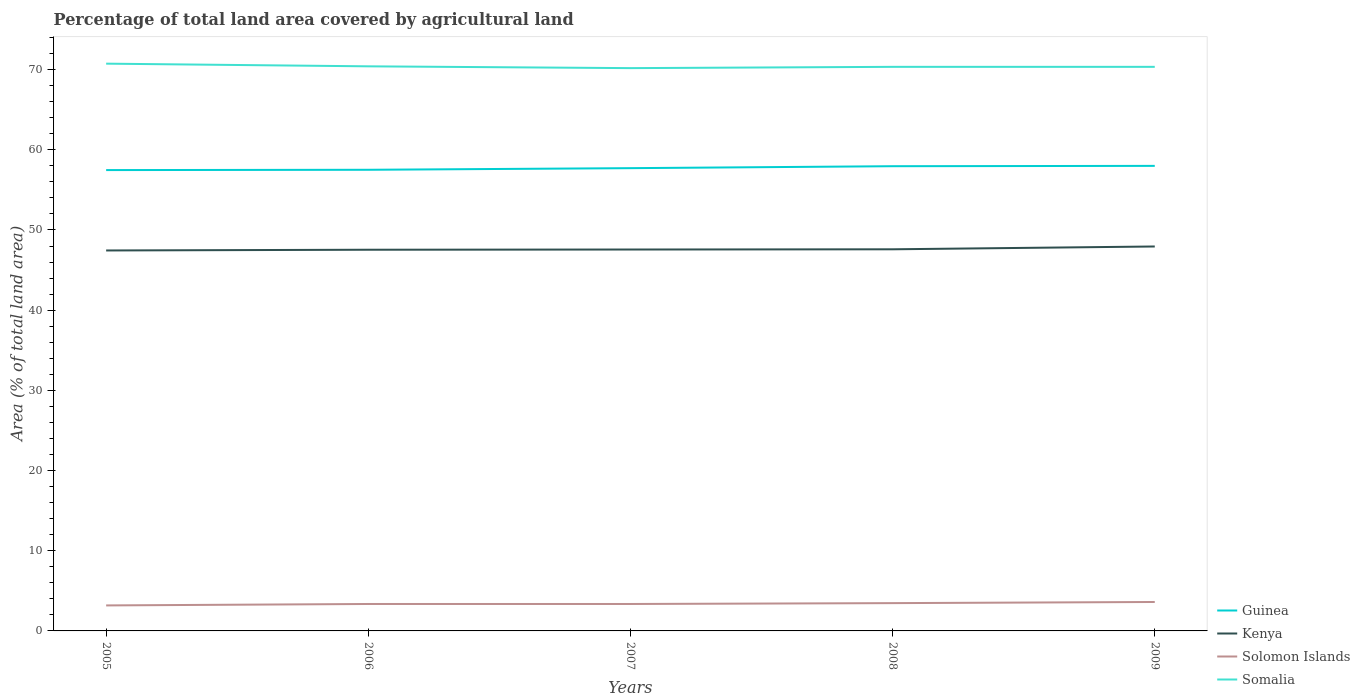Does the line corresponding to Solomon Islands intersect with the line corresponding to Kenya?
Your answer should be very brief. No. Across all years, what is the maximum percentage of agricultural land in Guinea?
Your answer should be very brief. 57.47. In which year was the percentage of agricultural land in Kenya maximum?
Offer a terse response. 2005. What is the total percentage of agricultural land in Guinea in the graph?
Your response must be concise. -0.2. What is the difference between the highest and the second highest percentage of agricultural land in Kenya?
Ensure brevity in your answer.  0.5. What is the difference between the highest and the lowest percentage of agricultural land in Guinea?
Make the answer very short. 2. Is the percentage of agricultural land in Guinea strictly greater than the percentage of agricultural land in Kenya over the years?
Provide a short and direct response. No. How many lines are there?
Ensure brevity in your answer.  4. What is the difference between two consecutive major ticks on the Y-axis?
Your answer should be compact. 10. Does the graph contain grids?
Your answer should be compact. No. How many legend labels are there?
Give a very brief answer. 4. What is the title of the graph?
Make the answer very short. Percentage of total land area covered by agricultural land. Does "Djibouti" appear as one of the legend labels in the graph?
Your answer should be very brief. No. What is the label or title of the Y-axis?
Provide a succinct answer. Area (% of total land area). What is the Area (% of total land area) of Guinea in 2005?
Your answer should be compact. 57.47. What is the Area (% of total land area) in Kenya in 2005?
Your response must be concise. 47.44. What is the Area (% of total land area) of Solomon Islands in 2005?
Give a very brief answer. 3.18. What is the Area (% of total land area) in Somalia in 2005?
Your response must be concise. 70.74. What is the Area (% of total land area) of Guinea in 2006?
Offer a very short reply. 57.5. What is the Area (% of total land area) in Kenya in 2006?
Make the answer very short. 47.53. What is the Area (% of total land area) in Solomon Islands in 2006?
Ensure brevity in your answer.  3.36. What is the Area (% of total land area) in Somalia in 2006?
Your answer should be compact. 70.41. What is the Area (% of total land area) of Guinea in 2007?
Provide a short and direct response. 57.71. What is the Area (% of total land area) in Kenya in 2007?
Keep it short and to the point. 47.56. What is the Area (% of total land area) of Solomon Islands in 2007?
Give a very brief answer. 3.36. What is the Area (% of total land area) of Somalia in 2007?
Offer a very short reply. 70.18. What is the Area (% of total land area) in Guinea in 2008?
Offer a terse response. 57.95. What is the Area (% of total land area) in Kenya in 2008?
Keep it short and to the point. 47.59. What is the Area (% of total land area) in Solomon Islands in 2008?
Your answer should be compact. 3.47. What is the Area (% of total land area) of Somalia in 2008?
Keep it short and to the point. 70.34. What is the Area (% of total land area) of Guinea in 2009?
Your response must be concise. 57.99. What is the Area (% of total land area) of Kenya in 2009?
Your answer should be compact. 47.94. What is the Area (% of total land area) in Solomon Islands in 2009?
Your response must be concise. 3.61. What is the Area (% of total land area) in Somalia in 2009?
Offer a very short reply. 70.34. Across all years, what is the maximum Area (% of total land area) in Guinea?
Your answer should be compact. 57.99. Across all years, what is the maximum Area (% of total land area) in Kenya?
Your answer should be very brief. 47.94. Across all years, what is the maximum Area (% of total land area) of Solomon Islands?
Your response must be concise. 3.61. Across all years, what is the maximum Area (% of total land area) of Somalia?
Ensure brevity in your answer.  70.74. Across all years, what is the minimum Area (% of total land area) of Guinea?
Provide a succinct answer. 57.47. Across all years, what is the minimum Area (% of total land area) of Kenya?
Offer a terse response. 47.44. Across all years, what is the minimum Area (% of total land area) in Solomon Islands?
Make the answer very short. 3.18. Across all years, what is the minimum Area (% of total land area) of Somalia?
Give a very brief answer. 70.18. What is the total Area (% of total land area) in Guinea in the graph?
Your response must be concise. 288.63. What is the total Area (% of total land area) of Kenya in the graph?
Your answer should be very brief. 238.07. What is the total Area (% of total land area) in Solomon Islands in the graph?
Your answer should be very brief. 16.97. What is the total Area (% of total land area) in Somalia in the graph?
Provide a succinct answer. 352.01. What is the difference between the Area (% of total land area) of Guinea in 2005 and that in 2006?
Your response must be concise. -0.04. What is the difference between the Area (% of total land area) of Kenya in 2005 and that in 2006?
Offer a terse response. -0.09. What is the difference between the Area (% of total land area) of Solomon Islands in 2005 and that in 2006?
Provide a succinct answer. -0.18. What is the difference between the Area (% of total land area) of Somalia in 2005 and that in 2006?
Your answer should be compact. 0.33. What is the difference between the Area (% of total land area) in Guinea in 2005 and that in 2007?
Offer a very short reply. -0.24. What is the difference between the Area (% of total land area) of Kenya in 2005 and that in 2007?
Offer a very short reply. -0.12. What is the difference between the Area (% of total land area) in Solomon Islands in 2005 and that in 2007?
Provide a succinct answer. -0.18. What is the difference between the Area (% of total land area) of Somalia in 2005 and that in 2007?
Your answer should be compact. 0.56. What is the difference between the Area (% of total land area) in Guinea in 2005 and that in 2008?
Keep it short and to the point. -0.48. What is the difference between the Area (% of total land area) in Kenya in 2005 and that in 2008?
Your answer should be very brief. -0.15. What is the difference between the Area (% of total land area) of Solomon Islands in 2005 and that in 2008?
Your answer should be compact. -0.29. What is the difference between the Area (% of total land area) of Somalia in 2005 and that in 2008?
Your response must be concise. 0.4. What is the difference between the Area (% of total land area) in Guinea in 2005 and that in 2009?
Offer a very short reply. -0.53. What is the difference between the Area (% of total land area) in Kenya in 2005 and that in 2009?
Offer a terse response. -0.5. What is the difference between the Area (% of total land area) in Solomon Islands in 2005 and that in 2009?
Provide a succinct answer. -0.43. What is the difference between the Area (% of total land area) in Somalia in 2005 and that in 2009?
Offer a terse response. 0.4. What is the difference between the Area (% of total land area) of Guinea in 2006 and that in 2007?
Provide a succinct answer. -0.2. What is the difference between the Area (% of total land area) in Kenya in 2006 and that in 2007?
Keep it short and to the point. -0.03. What is the difference between the Area (% of total land area) in Somalia in 2006 and that in 2007?
Your response must be concise. 0.22. What is the difference between the Area (% of total land area) in Guinea in 2006 and that in 2008?
Make the answer very short. -0.45. What is the difference between the Area (% of total land area) in Kenya in 2006 and that in 2008?
Your answer should be compact. -0.05. What is the difference between the Area (% of total land area) of Solomon Islands in 2006 and that in 2008?
Your answer should be compact. -0.11. What is the difference between the Area (% of total land area) in Somalia in 2006 and that in 2008?
Your answer should be compact. 0.06. What is the difference between the Area (% of total land area) in Guinea in 2006 and that in 2009?
Make the answer very short. -0.49. What is the difference between the Area (% of total land area) of Kenya in 2006 and that in 2009?
Make the answer very short. -0.41. What is the difference between the Area (% of total land area) of Solomon Islands in 2006 and that in 2009?
Keep it short and to the point. -0.25. What is the difference between the Area (% of total land area) in Somalia in 2006 and that in 2009?
Make the answer very short. 0.06. What is the difference between the Area (% of total land area) in Guinea in 2007 and that in 2008?
Keep it short and to the point. -0.24. What is the difference between the Area (% of total land area) in Kenya in 2007 and that in 2008?
Offer a very short reply. -0.03. What is the difference between the Area (% of total land area) of Solomon Islands in 2007 and that in 2008?
Offer a very short reply. -0.11. What is the difference between the Area (% of total land area) in Somalia in 2007 and that in 2008?
Make the answer very short. -0.16. What is the difference between the Area (% of total land area) in Guinea in 2007 and that in 2009?
Keep it short and to the point. -0.28. What is the difference between the Area (% of total land area) of Kenya in 2007 and that in 2009?
Offer a very short reply. -0.38. What is the difference between the Area (% of total land area) in Solomon Islands in 2007 and that in 2009?
Ensure brevity in your answer.  -0.25. What is the difference between the Area (% of total land area) in Somalia in 2007 and that in 2009?
Offer a terse response. -0.16. What is the difference between the Area (% of total land area) of Guinea in 2008 and that in 2009?
Your response must be concise. -0.04. What is the difference between the Area (% of total land area) in Kenya in 2008 and that in 2009?
Your answer should be very brief. -0.35. What is the difference between the Area (% of total land area) of Solomon Islands in 2008 and that in 2009?
Your answer should be compact. -0.14. What is the difference between the Area (% of total land area) of Guinea in 2005 and the Area (% of total land area) of Kenya in 2006?
Offer a very short reply. 9.93. What is the difference between the Area (% of total land area) of Guinea in 2005 and the Area (% of total land area) of Solomon Islands in 2006?
Give a very brief answer. 54.11. What is the difference between the Area (% of total land area) of Guinea in 2005 and the Area (% of total land area) of Somalia in 2006?
Your answer should be very brief. -12.94. What is the difference between the Area (% of total land area) of Kenya in 2005 and the Area (% of total land area) of Solomon Islands in 2006?
Make the answer very short. 44.09. What is the difference between the Area (% of total land area) in Kenya in 2005 and the Area (% of total land area) in Somalia in 2006?
Your response must be concise. -22.96. What is the difference between the Area (% of total land area) in Solomon Islands in 2005 and the Area (% of total land area) in Somalia in 2006?
Ensure brevity in your answer.  -67.23. What is the difference between the Area (% of total land area) in Guinea in 2005 and the Area (% of total land area) in Kenya in 2007?
Give a very brief answer. 9.9. What is the difference between the Area (% of total land area) in Guinea in 2005 and the Area (% of total land area) in Solomon Islands in 2007?
Your answer should be very brief. 54.11. What is the difference between the Area (% of total land area) of Guinea in 2005 and the Area (% of total land area) of Somalia in 2007?
Provide a succinct answer. -12.71. What is the difference between the Area (% of total land area) in Kenya in 2005 and the Area (% of total land area) in Solomon Islands in 2007?
Make the answer very short. 44.09. What is the difference between the Area (% of total land area) of Kenya in 2005 and the Area (% of total land area) of Somalia in 2007?
Keep it short and to the point. -22.74. What is the difference between the Area (% of total land area) of Solomon Islands in 2005 and the Area (% of total land area) of Somalia in 2007?
Your response must be concise. -67. What is the difference between the Area (% of total land area) in Guinea in 2005 and the Area (% of total land area) in Kenya in 2008?
Your answer should be compact. 9.88. What is the difference between the Area (% of total land area) of Guinea in 2005 and the Area (% of total land area) of Solomon Islands in 2008?
Offer a very short reply. 54. What is the difference between the Area (% of total land area) in Guinea in 2005 and the Area (% of total land area) in Somalia in 2008?
Keep it short and to the point. -12.87. What is the difference between the Area (% of total land area) in Kenya in 2005 and the Area (% of total land area) in Solomon Islands in 2008?
Provide a succinct answer. 43.98. What is the difference between the Area (% of total land area) of Kenya in 2005 and the Area (% of total land area) of Somalia in 2008?
Offer a very short reply. -22.9. What is the difference between the Area (% of total land area) in Solomon Islands in 2005 and the Area (% of total land area) in Somalia in 2008?
Your response must be concise. -67.16. What is the difference between the Area (% of total land area) of Guinea in 2005 and the Area (% of total land area) of Kenya in 2009?
Ensure brevity in your answer.  9.53. What is the difference between the Area (% of total land area) in Guinea in 2005 and the Area (% of total land area) in Solomon Islands in 2009?
Your answer should be very brief. 53.86. What is the difference between the Area (% of total land area) of Guinea in 2005 and the Area (% of total land area) of Somalia in 2009?
Your answer should be very brief. -12.87. What is the difference between the Area (% of total land area) of Kenya in 2005 and the Area (% of total land area) of Solomon Islands in 2009?
Keep it short and to the point. 43.84. What is the difference between the Area (% of total land area) of Kenya in 2005 and the Area (% of total land area) of Somalia in 2009?
Your response must be concise. -22.9. What is the difference between the Area (% of total land area) in Solomon Islands in 2005 and the Area (% of total land area) in Somalia in 2009?
Offer a very short reply. -67.16. What is the difference between the Area (% of total land area) of Guinea in 2006 and the Area (% of total land area) of Kenya in 2007?
Ensure brevity in your answer.  9.94. What is the difference between the Area (% of total land area) of Guinea in 2006 and the Area (% of total land area) of Solomon Islands in 2007?
Provide a succinct answer. 54.15. What is the difference between the Area (% of total land area) in Guinea in 2006 and the Area (% of total land area) in Somalia in 2007?
Provide a succinct answer. -12.68. What is the difference between the Area (% of total land area) in Kenya in 2006 and the Area (% of total land area) in Solomon Islands in 2007?
Your answer should be compact. 44.18. What is the difference between the Area (% of total land area) of Kenya in 2006 and the Area (% of total land area) of Somalia in 2007?
Ensure brevity in your answer.  -22.65. What is the difference between the Area (% of total land area) in Solomon Islands in 2006 and the Area (% of total land area) in Somalia in 2007?
Make the answer very short. -66.82. What is the difference between the Area (% of total land area) in Guinea in 2006 and the Area (% of total land area) in Kenya in 2008?
Provide a succinct answer. 9.92. What is the difference between the Area (% of total land area) of Guinea in 2006 and the Area (% of total land area) of Solomon Islands in 2008?
Give a very brief answer. 54.04. What is the difference between the Area (% of total land area) of Guinea in 2006 and the Area (% of total land area) of Somalia in 2008?
Offer a terse response. -12.84. What is the difference between the Area (% of total land area) in Kenya in 2006 and the Area (% of total land area) in Solomon Islands in 2008?
Your answer should be very brief. 44.07. What is the difference between the Area (% of total land area) of Kenya in 2006 and the Area (% of total land area) of Somalia in 2008?
Provide a short and direct response. -22.81. What is the difference between the Area (% of total land area) of Solomon Islands in 2006 and the Area (% of total land area) of Somalia in 2008?
Make the answer very short. -66.98. What is the difference between the Area (% of total land area) of Guinea in 2006 and the Area (% of total land area) of Kenya in 2009?
Give a very brief answer. 9.56. What is the difference between the Area (% of total land area) of Guinea in 2006 and the Area (% of total land area) of Solomon Islands in 2009?
Provide a succinct answer. 53.9. What is the difference between the Area (% of total land area) in Guinea in 2006 and the Area (% of total land area) in Somalia in 2009?
Ensure brevity in your answer.  -12.84. What is the difference between the Area (% of total land area) of Kenya in 2006 and the Area (% of total land area) of Solomon Islands in 2009?
Provide a short and direct response. 43.93. What is the difference between the Area (% of total land area) of Kenya in 2006 and the Area (% of total land area) of Somalia in 2009?
Keep it short and to the point. -22.81. What is the difference between the Area (% of total land area) in Solomon Islands in 2006 and the Area (% of total land area) in Somalia in 2009?
Offer a terse response. -66.98. What is the difference between the Area (% of total land area) in Guinea in 2007 and the Area (% of total land area) in Kenya in 2008?
Ensure brevity in your answer.  10.12. What is the difference between the Area (% of total land area) in Guinea in 2007 and the Area (% of total land area) in Solomon Islands in 2008?
Offer a terse response. 54.24. What is the difference between the Area (% of total land area) in Guinea in 2007 and the Area (% of total land area) in Somalia in 2008?
Make the answer very short. -12.63. What is the difference between the Area (% of total land area) in Kenya in 2007 and the Area (% of total land area) in Solomon Islands in 2008?
Your response must be concise. 44.1. What is the difference between the Area (% of total land area) of Kenya in 2007 and the Area (% of total land area) of Somalia in 2008?
Give a very brief answer. -22.78. What is the difference between the Area (% of total land area) of Solomon Islands in 2007 and the Area (% of total land area) of Somalia in 2008?
Offer a terse response. -66.98. What is the difference between the Area (% of total land area) of Guinea in 2007 and the Area (% of total land area) of Kenya in 2009?
Your answer should be compact. 9.77. What is the difference between the Area (% of total land area) of Guinea in 2007 and the Area (% of total land area) of Solomon Islands in 2009?
Offer a terse response. 54.1. What is the difference between the Area (% of total land area) in Guinea in 2007 and the Area (% of total land area) in Somalia in 2009?
Keep it short and to the point. -12.63. What is the difference between the Area (% of total land area) in Kenya in 2007 and the Area (% of total land area) in Solomon Islands in 2009?
Your response must be concise. 43.95. What is the difference between the Area (% of total land area) in Kenya in 2007 and the Area (% of total land area) in Somalia in 2009?
Your answer should be compact. -22.78. What is the difference between the Area (% of total land area) in Solomon Islands in 2007 and the Area (% of total land area) in Somalia in 2009?
Your response must be concise. -66.98. What is the difference between the Area (% of total land area) in Guinea in 2008 and the Area (% of total land area) in Kenya in 2009?
Ensure brevity in your answer.  10.01. What is the difference between the Area (% of total land area) of Guinea in 2008 and the Area (% of total land area) of Solomon Islands in 2009?
Your answer should be very brief. 54.34. What is the difference between the Area (% of total land area) of Guinea in 2008 and the Area (% of total land area) of Somalia in 2009?
Offer a very short reply. -12.39. What is the difference between the Area (% of total land area) in Kenya in 2008 and the Area (% of total land area) in Solomon Islands in 2009?
Ensure brevity in your answer.  43.98. What is the difference between the Area (% of total land area) in Kenya in 2008 and the Area (% of total land area) in Somalia in 2009?
Offer a very short reply. -22.75. What is the difference between the Area (% of total land area) of Solomon Islands in 2008 and the Area (% of total land area) of Somalia in 2009?
Offer a terse response. -66.88. What is the average Area (% of total land area) in Guinea per year?
Provide a short and direct response. 57.73. What is the average Area (% of total land area) of Kenya per year?
Your answer should be compact. 47.61. What is the average Area (% of total land area) in Solomon Islands per year?
Provide a succinct answer. 3.39. What is the average Area (% of total land area) in Somalia per year?
Your answer should be very brief. 70.4. In the year 2005, what is the difference between the Area (% of total land area) in Guinea and Area (% of total land area) in Kenya?
Give a very brief answer. 10.02. In the year 2005, what is the difference between the Area (% of total land area) in Guinea and Area (% of total land area) in Solomon Islands?
Keep it short and to the point. 54.29. In the year 2005, what is the difference between the Area (% of total land area) in Guinea and Area (% of total land area) in Somalia?
Offer a terse response. -13.27. In the year 2005, what is the difference between the Area (% of total land area) of Kenya and Area (% of total land area) of Solomon Islands?
Keep it short and to the point. 44.26. In the year 2005, what is the difference between the Area (% of total land area) in Kenya and Area (% of total land area) in Somalia?
Offer a very short reply. -23.29. In the year 2005, what is the difference between the Area (% of total land area) in Solomon Islands and Area (% of total land area) in Somalia?
Your answer should be very brief. -67.56. In the year 2006, what is the difference between the Area (% of total land area) in Guinea and Area (% of total land area) in Kenya?
Your response must be concise. 9.97. In the year 2006, what is the difference between the Area (% of total land area) in Guinea and Area (% of total land area) in Solomon Islands?
Ensure brevity in your answer.  54.15. In the year 2006, what is the difference between the Area (% of total land area) of Guinea and Area (% of total land area) of Somalia?
Ensure brevity in your answer.  -12.9. In the year 2006, what is the difference between the Area (% of total land area) in Kenya and Area (% of total land area) in Solomon Islands?
Offer a terse response. 44.18. In the year 2006, what is the difference between the Area (% of total land area) in Kenya and Area (% of total land area) in Somalia?
Give a very brief answer. -22.87. In the year 2006, what is the difference between the Area (% of total land area) of Solomon Islands and Area (% of total land area) of Somalia?
Offer a terse response. -67.05. In the year 2007, what is the difference between the Area (% of total land area) of Guinea and Area (% of total land area) of Kenya?
Provide a short and direct response. 10.14. In the year 2007, what is the difference between the Area (% of total land area) in Guinea and Area (% of total land area) in Solomon Islands?
Give a very brief answer. 54.35. In the year 2007, what is the difference between the Area (% of total land area) of Guinea and Area (% of total land area) of Somalia?
Your response must be concise. -12.47. In the year 2007, what is the difference between the Area (% of total land area) of Kenya and Area (% of total land area) of Solomon Islands?
Make the answer very short. 44.2. In the year 2007, what is the difference between the Area (% of total land area) of Kenya and Area (% of total land area) of Somalia?
Give a very brief answer. -22.62. In the year 2007, what is the difference between the Area (% of total land area) of Solomon Islands and Area (% of total land area) of Somalia?
Your answer should be very brief. -66.82. In the year 2008, what is the difference between the Area (% of total land area) of Guinea and Area (% of total land area) of Kenya?
Your answer should be compact. 10.36. In the year 2008, what is the difference between the Area (% of total land area) of Guinea and Area (% of total land area) of Solomon Islands?
Ensure brevity in your answer.  54.49. In the year 2008, what is the difference between the Area (% of total land area) in Guinea and Area (% of total land area) in Somalia?
Your response must be concise. -12.39. In the year 2008, what is the difference between the Area (% of total land area) of Kenya and Area (% of total land area) of Solomon Islands?
Keep it short and to the point. 44.12. In the year 2008, what is the difference between the Area (% of total land area) of Kenya and Area (% of total land area) of Somalia?
Offer a very short reply. -22.75. In the year 2008, what is the difference between the Area (% of total land area) of Solomon Islands and Area (% of total land area) of Somalia?
Give a very brief answer. -66.88. In the year 2009, what is the difference between the Area (% of total land area) in Guinea and Area (% of total land area) in Kenya?
Provide a short and direct response. 10.05. In the year 2009, what is the difference between the Area (% of total land area) in Guinea and Area (% of total land area) in Solomon Islands?
Make the answer very short. 54.38. In the year 2009, what is the difference between the Area (% of total land area) in Guinea and Area (% of total land area) in Somalia?
Offer a very short reply. -12.35. In the year 2009, what is the difference between the Area (% of total land area) of Kenya and Area (% of total land area) of Solomon Islands?
Your answer should be compact. 44.33. In the year 2009, what is the difference between the Area (% of total land area) of Kenya and Area (% of total land area) of Somalia?
Give a very brief answer. -22.4. In the year 2009, what is the difference between the Area (% of total land area) in Solomon Islands and Area (% of total land area) in Somalia?
Offer a very short reply. -66.73. What is the ratio of the Area (% of total land area) in Guinea in 2005 to that in 2006?
Your response must be concise. 1. What is the ratio of the Area (% of total land area) in Kenya in 2005 to that in 2006?
Provide a short and direct response. 1. What is the ratio of the Area (% of total land area) in Solomon Islands in 2005 to that in 2006?
Give a very brief answer. 0.95. What is the ratio of the Area (% of total land area) in Somalia in 2005 to that in 2006?
Your response must be concise. 1. What is the ratio of the Area (% of total land area) in Guinea in 2005 to that in 2007?
Provide a short and direct response. 1. What is the ratio of the Area (% of total land area) of Kenya in 2005 to that in 2007?
Your response must be concise. 1. What is the ratio of the Area (% of total land area) of Solomon Islands in 2005 to that in 2007?
Offer a very short reply. 0.95. What is the ratio of the Area (% of total land area) in Somalia in 2005 to that in 2007?
Provide a succinct answer. 1.01. What is the ratio of the Area (% of total land area) of Guinea in 2005 to that in 2008?
Make the answer very short. 0.99. What is the ratio of the Area (% of total land area) of Solomon Islands in 2005 to that in 2008?
Ensure brevity in your answer.  0.92. What is the ratio of the Area (% of total land area) of Somalia in 2005 to that in 2008?
Keep it short and to the point. 1.01. What is the ratio of the Area (% of total land area) in Guinea in 2005 to that in 2009?
Provide a short and direct response. 0.99. What is the ratio of the Area (% of total land area) of Solomon Islands in 2005 to that in 2009?
Offer a terse response. 0.88. What is the ratio of the Area (% of total land area) of Somalia in 2005 to that in 2009?
Offer a very short reply. 1.01. What is the ratio of the Area (% of total land area) in Guinea in 2006 to that in 2007?
Your response must be concise. 1. What is the ratio of the Area (% of total land area) in Kenya in 2006 to that in 2007?
Keep it short and to the point. 1. What is the ratio of the Area (% of total land area) in Solomon Islands in 2006 to that in 2007?
Offer a very short reply. 1. What is the ratio of the Area (% of total land area) in Guinea in 2006 to that in 2008?
Provide a short and direct response. 0.99. What is the ratio of the Area (% of total land area) of Kenya in 2006 to that in 2008?
Your answer should be very brief. 1. What is the ratio of the Area (% of total land area) in Solomon Islands in 2006 to that in 2008?
Your answer should be very brief. 0.97. What is the ratio of the Area (% of total land area) in Kenya in 2006 to that in 2009?
Keep it short and to the point. 0.99. What is the ratio of the Area (% of total land area) of Solomon Islands in 2006 to that in 2009?
Provide a short and direct response. 0.93. What is the ratio of the Area (% of total land area) of Guinea in 2007 to that in 2008?
Offer a very short reply. 1. What is the ratio of the Area (% of total land area) in Kenya in 2007 to that in 2008?
Your answer should be very brief. 1. What is the ratio of the Area (% of total land area) in Solomon Islands in 2007 to that in 2008?
Make the answer very short. 0.97. What is the ratio of the Area (% of total land area) in Guinea in 2007 to that in 2009?
Give a very brief answer. 1. What is the ratio of the Area (% of total land area) of Kenya in 2007 to that in 2009?
Offer a very short reply. 0.99. What is the ratio of the Area (% of total land area) of Solomon Islands in 2007 to that in 2009?
Keep it short and to the point. 0.93. What is the ratio of the Area (% of total land area) of Somalia in 2007 to that in 2009?
Provide a succinct answer. 1. What is the ratio of the Area (% of total land area) in Kenya in 2008 to that in 2009?
Your answer should be very brief. 0.99. What is the ratio of the Area (% of total land area) in Solomon Islands in 2008 to that in 2009?
Your answer should be very brief. 0.96. What is the ratio of the Area (% of total land area) in Somalia in 2008 to that in 2009?
Your response must be concise. 1. What is the difference between the highest and the second highest Area (% of total land area) in Guinea?
Keep it short and to the point. 0.04. What is the difference between the highest and the second highest Area (% of total land area) of Kenya?
Provide a short and direct response. 0.35. What is the difference between the highest and the second highest Area (% of total land area) in Solomon Islands?
Keep it short and to the point. 0.14. What is the difference between the highest and the second highest Area (% of total land area) in Somalia?
Make the answer very short. 0.33. What is the difference between the highest and the lowest Area (% of total land area) of Guinea?
Offer a terse response. 0.53. What is the difference between the highest and the lowest Area (% of total land area) in Kenya?
Ensure brevity in your answer.  0.5. What is the difference between the highest and the lowest Area (% of total land area) in Solomon Islands?
Your response must be concise. 0.43. What is the difference between the highest and the lowest Area (% of total land area) in Somalia?
Your response must be concise. 0.56. 